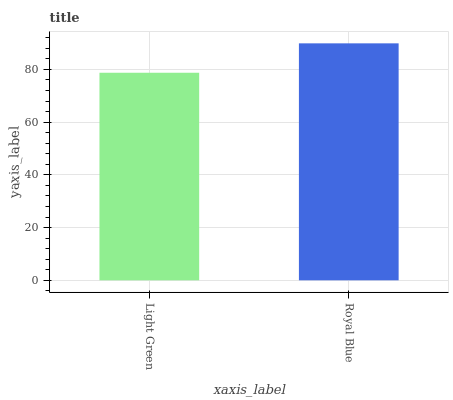Is Royal Blue the minimum?
Answer yes or no. No. Is Royal Blue greater than Light Green?
Answer yes or no. Yes. Is Light Green less than Royal Blue?
Answer yes or no. Yes. Is Light Green greater than Royal Blue?
Answer yes or no. No. Is Royal Blue less than Light Green?
Answer yes or no. No. Is Royal Blue the high median?
Answer yes or no. Yes. Is Light Green the low median?
Answer yes or no. Yes. Is Light Green the high median?
Answer yes or no. No. Is Royal Blue the low median?
Answer yes or no. No. 